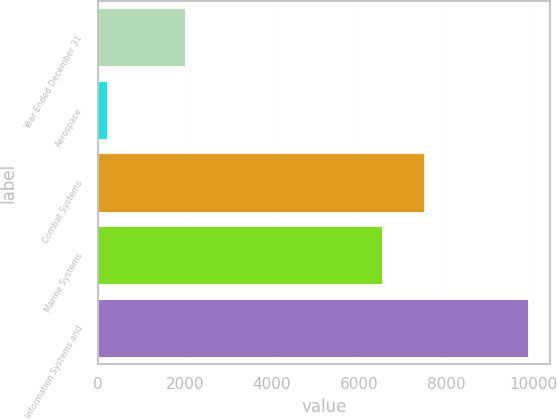Convert chart. <chart><loc_0><loc_0><loc_500><loc_500><bar_chart><fcel>Year Ended December 31<fcel>Aerospace<fcel>Combat Systems<fcel>Marine Systems<fcel>Information Systems and<nl><fcel>2010<fcel>220<fcel>7484.8<fcel>6518<fcel>9888<nl></chart> 